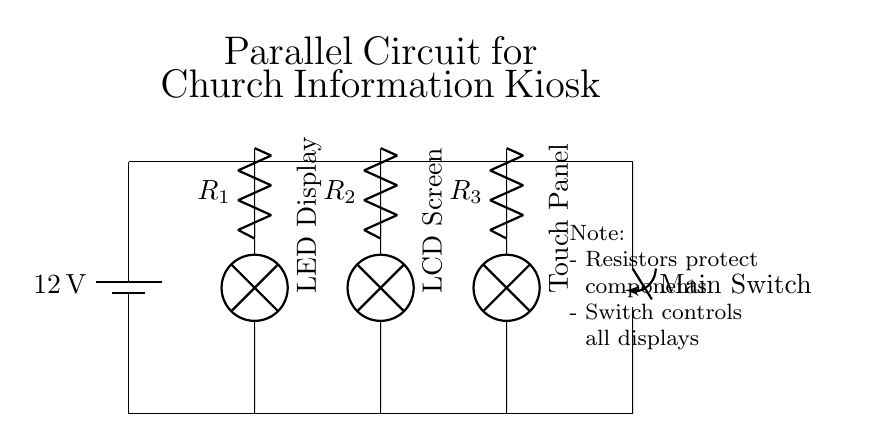What is the voltage of this circuit? The voltage source at the top of the circuit is labeled as 12 volts, which is the potential difference available across the circuit.
Answer: 12 volts What type of circuit configuration is used here? The circuit diagram shows multiple components connected across the same voltage source, meaning each component operates independently; hence, it is a parallel circuit.
Answer: Parallel How many components are connected in parallel? There are three components (LED Display, LCD Screen, and Touch Panel) connected in parallel, each connecting directly to the voltage source without interdependence.
Answer: Three What is the purpose of the resistors in the circuit? The resistors are labeled as R1, R2, and R3, and they are used to limit the current through each component, protecting them from excessive current that may cause damage.
Answer: Current limiting What can be inferred if one component fails? In a parallel circuit, if one component fails (like an LED Display), the other components (LCD Screen, Touch Panel) will continue to operate since they are connected independently.
Answer: Other components continue working What does the main switch control in this circuit? The main switch, located at the end of the circuit, controls the power to all connected components, allowing the entire system to be turned on or off simultaneously.
Answer: All displays 